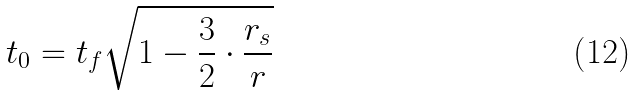Convert formula to latex. <formula><loc_0><loc_0><loc_500><loc_500>t _ { 0 } = t _ { f } \sqrt { 1 - \frac { 3 } { 2 } \cdot \frac { r _ { s } } { r } }</formula> 